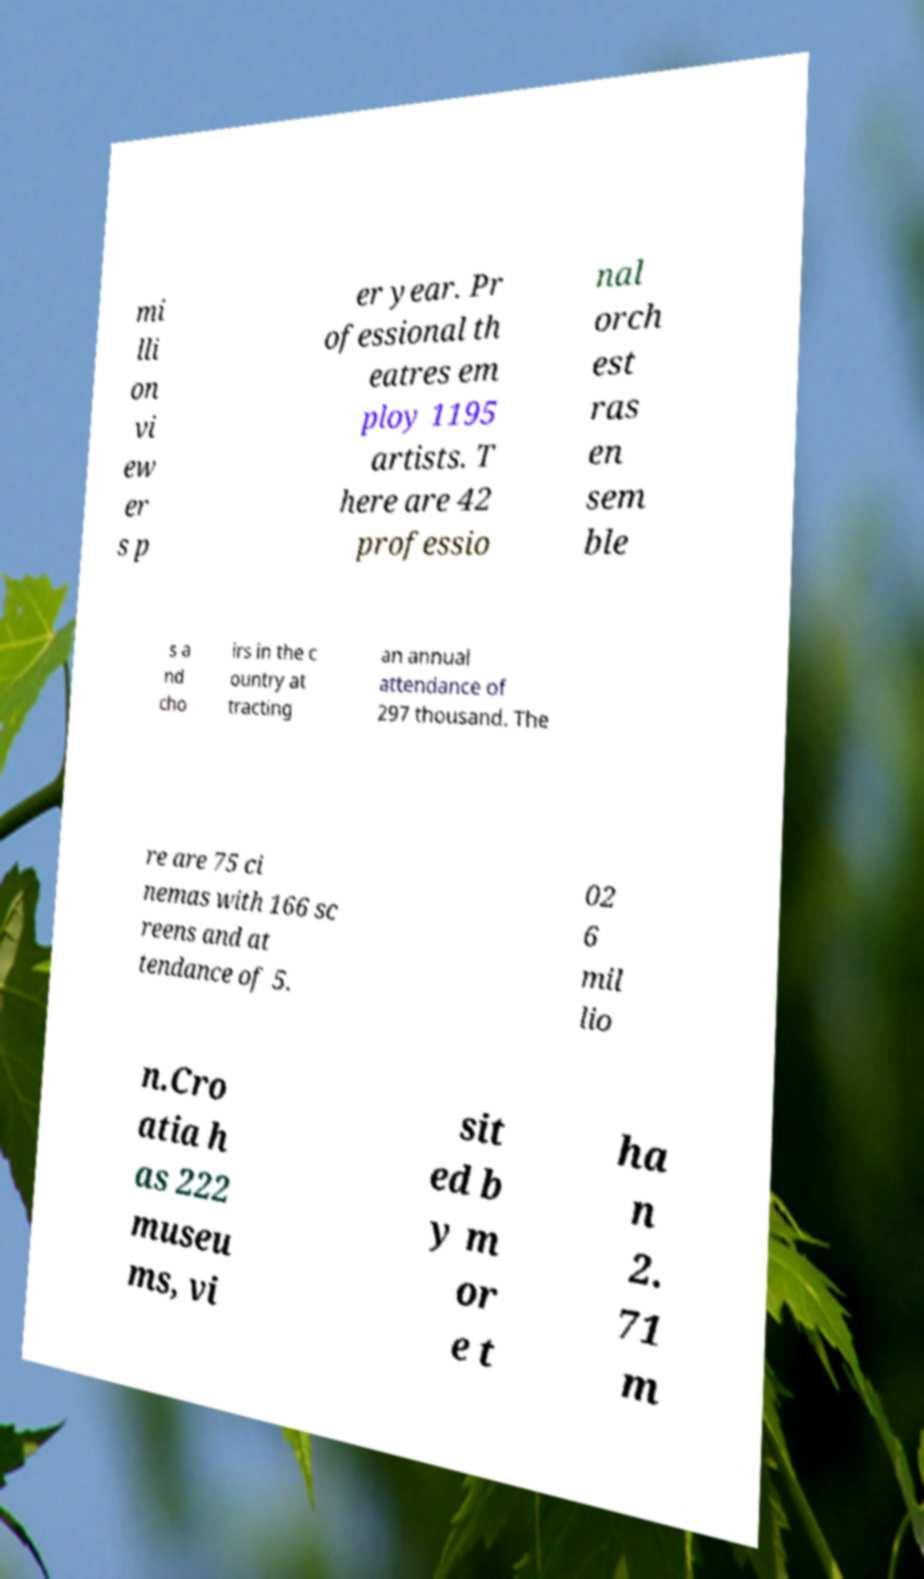For documentation purposes, I need the text within this image transcribed. Could you provide that? mi lli on vi ew er s p er year. Pr ofessional th eatres em ploy 1195 artists. T here are 42 professio nal orch est ras en sem ble s a nd cho irs in the c ountry at tracting an annual attendance of 297 thousand. The re are 75 ci nemas with 166 sc reens and at tendance of 5. 02 6 mil lio n.Cro atia h as 222 museu ms, vi sit ed b y m or e t ha n 2. 71 m 